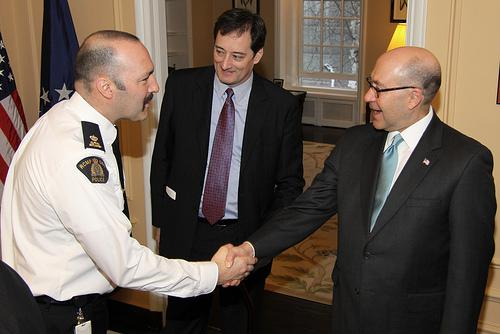Question: who are in the photo?
Choices:
A. Girls.
B. Boys.
C. Men.
D. People.
Answer with the letter. Answer: D Question: what is the right man wearing?
Choices:
A. Tie.
B. Watch.
C. Loafers.
D. Glasses.
Answer with the letter. Answer: D Question: where was the photo taken?
Choices:
A. Outside a room.
B. In a pool.
C. Inside a room.
D. Outside.
Answer with the letter. Answer: C 